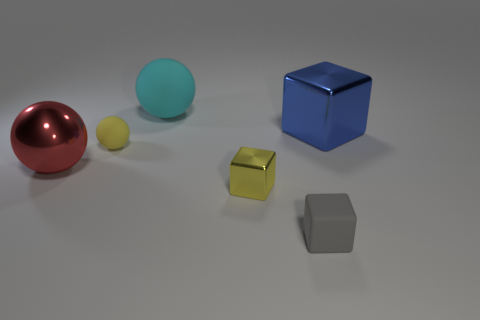What materials do the objects in the image appear to be made of? The objects in the image seem to have a variety of surfaces: the red and cyan objects look like they have a matte finish; the yellow and blue objects give off reflections suggesting they might be metallic; while the grey object appears to have a dull, possibly plastic-like surface. 